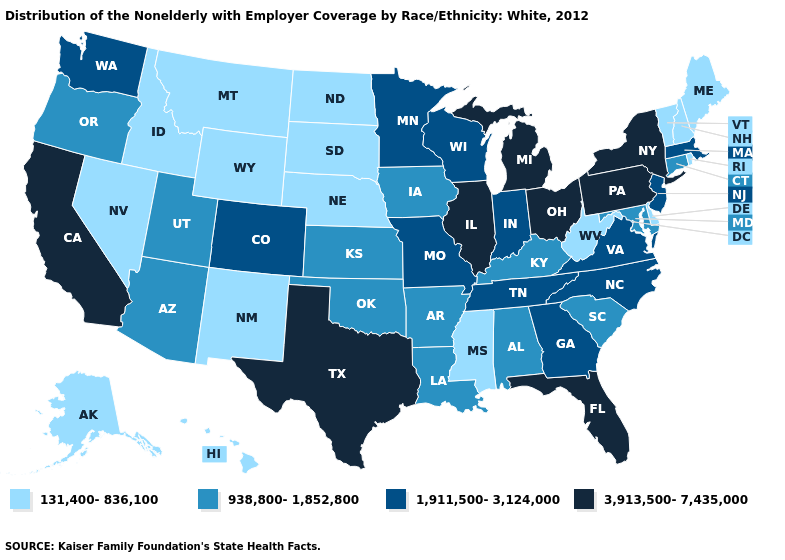Does Hawaii have the highest value in the USA?
Write a very short answer. No. How many symbols are there in the legend?
Concise answer only. 4. What is the lowest value in the USA?
Quick response, please. 131,400-836,100. Name the states that have a value in the range 131,400-836,100?
Keep it brief. Alaska, Delaware, Hawaii, Idaho, Maine, Mississippi, Montana, Nebraska, Nevada, New Hampshire, New Mexico, North Dakota, Rhode Island, South Dakota, Vermont, West Virginia, Wyoming. Name the states that have a value in the range 131,400-836,100?
Write a very short answer. Alaska, Delaware, Hawaii, Idaho, Maine, Mississippi, Montana, Nebraska, Nevada, New Hampshire, New Mexico, North Dakota, Rhode Island, South Dakota, Vermont, West Virginia, Wyoming. How many symbols are there in the legend?
Quick response, please. 4. What is the value of Mississippi?
Write a very short answer. 131,400-836,100. How many symbols are there in the legend?
Write a very short answer. 4. What is the value of Maryland?
Keep it brief. 938,800-1,852,800. Does California have the lowest value in the West?
Give a very brief answer. No. Which states hav the highest value in the South?
Write a very short answer. Florida, Texas. Which states have the lowest value in the USA?
Give a very brief answer. Alaska, Delaware, Hawaii, Idaho, Maine, Mississippi, Montana, Nebraska, Nevada, New Hampshire, New Mexico, North Dakota, Rhode Island, South Dakota, Vermont, West Virginia, Wyoming. Which states have the lowest value in the USA?
Be succinct. Alaska, Delaware, Hawaii, Idaho, Maine, Mississippi, Montana, Nebraska, Nevada, New Hampshire, New Mexico, North Dakota, Rhode Island, South Dakota, Vermont, West Virginia, Wyoming. Which states have the highest value in the USA?
Give a very brief answer. California, Florida, Illinois, Michigan, New York, Ohio, Pennsylvania, Texas. 